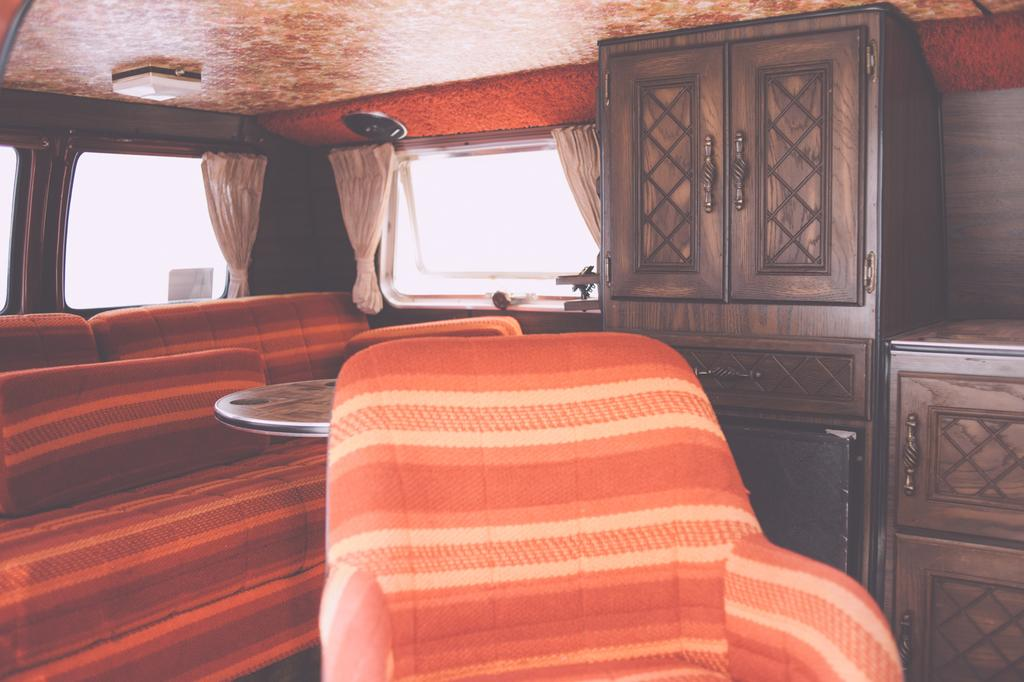What type of space is depicted in the image? The image is of the inside of a room. What type of furniture is present in the room? There is a sofa and a chair in the room. What type of storage is available in the room? There are wooden cupboards in the room. What type of window treatment is present in the room? There are curtains in the room. Is there a veil covering the sofa in the image? No, there is no veil present in the image. What type of gardening tool can be seen in the image? There are no gardening tools, such as a rake, present in the image. 